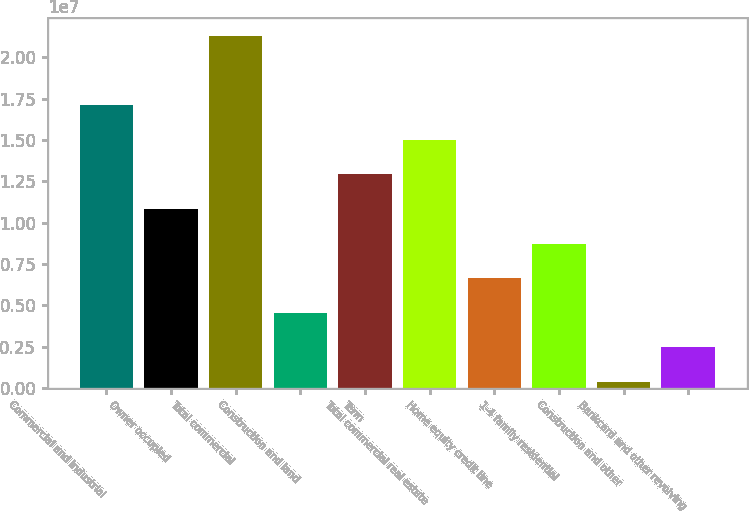<chart> <loc_0><loc_0><loc_500><loc_500><bar_chart><fcel>Commercial and industrial<fcel>Owner occupied<fcel>Total commercial<fcel>Construction and land<fcel>Term<fcel>Total commercial real estate<fcel>Home equity credit line<fcel>1-4 family residential<fcel>Construction and other<fcel>Bankcard and other revolving<nl><fcel>1.71105e+07<fcel>1.0829e+07<fcel>2.12982e+07<fcel>4.54742e+06<fcel>1.29228e+07<fcel>1.50166e+07<fcel>6.64126e+06<fcel>8.73511e+06<fcel>359723<fcel>2.45357e+06<nl></chart> 